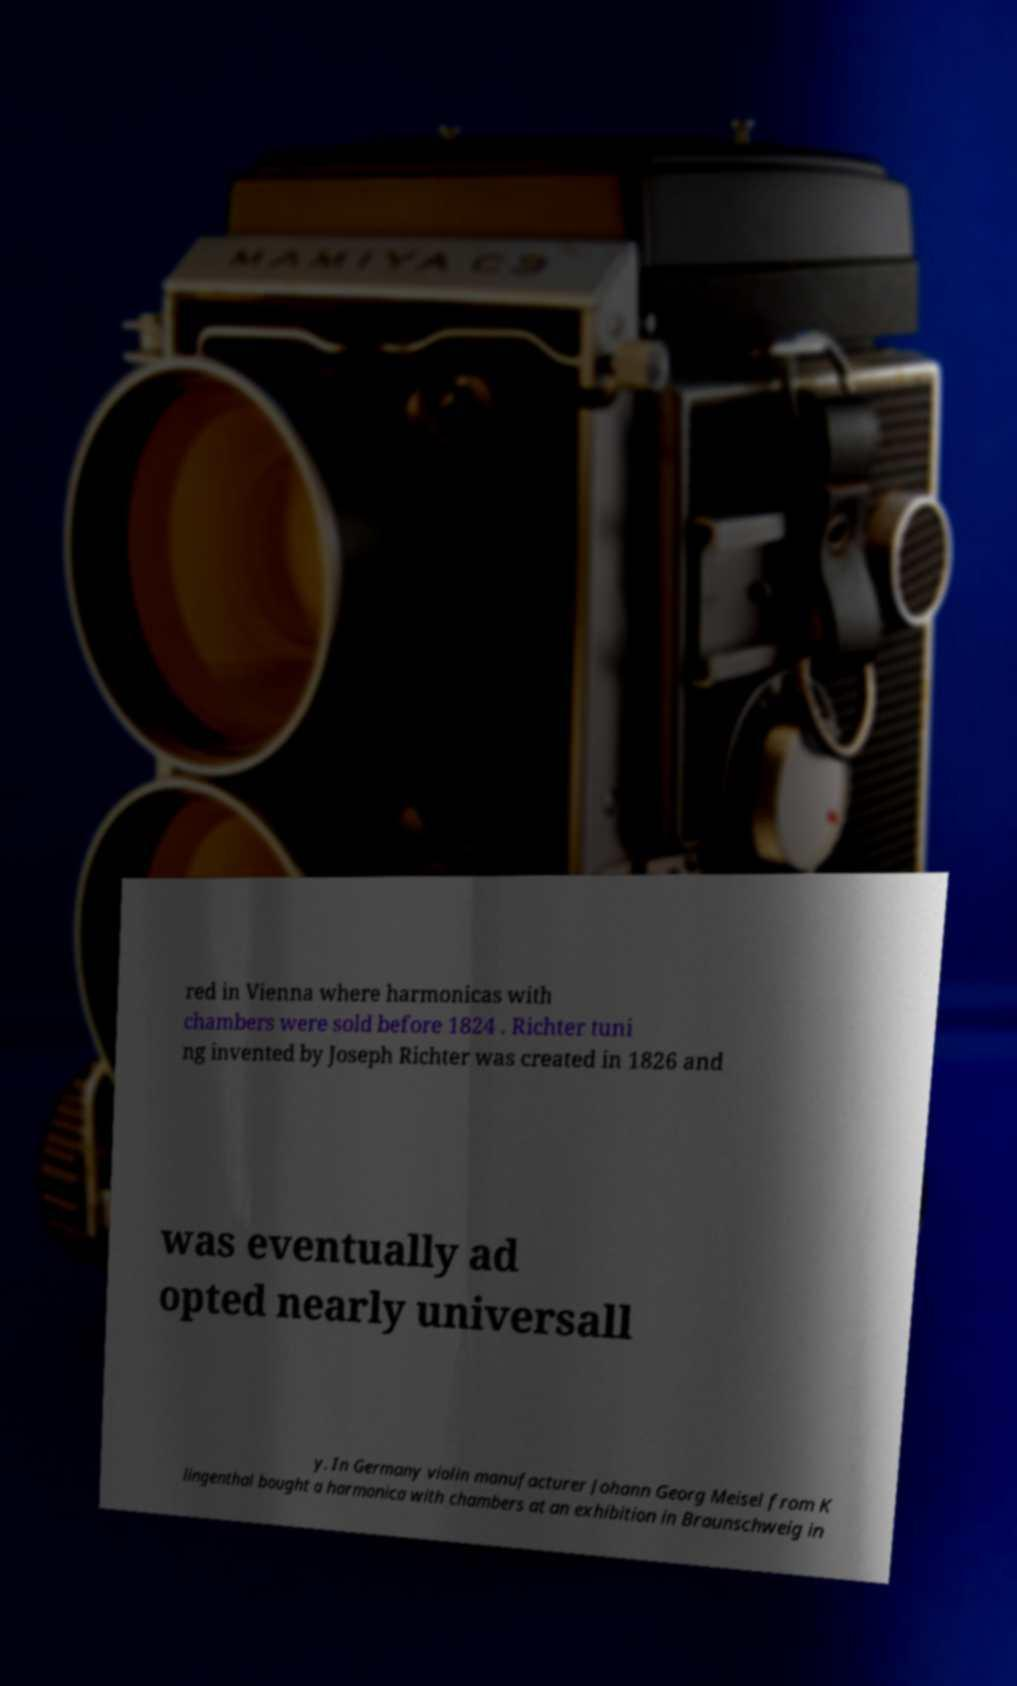Can you read and provide the text displayed in the image?This photo seems to have some interesting text. Can you extract and type it out for me? red in Vienna where harmonicas with chambers were sold before 1824 . Richter tuni ng invented by Joseph Richter was created in 1826 and was eventually ad opted nearly universall y. In Germany violin manufacturer Johann Georg Meisel from K lingenthal bought a harmonica with chambers at an exhibition in Braunschweig in 